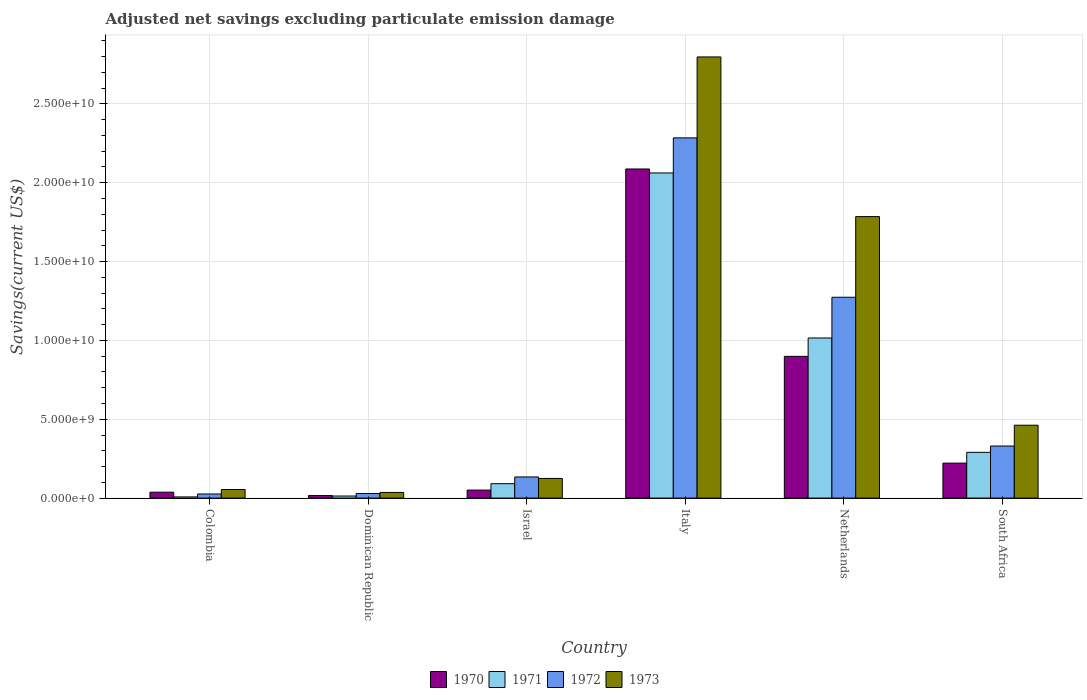How many bars are there on the 1st tick from the left?
Provide a succinct answer. 4. How many bars are there on the 3rd tick from the right?
Offer a very short reply. 4. What is the label of the 3rd group of bars from the left?
Make the answer very short. Israel. In how many cases, is the number of bars for a given country not equal to the number of legend labels?
Provide a succinct answer. 0. What is the adjusted net savings in 1972 in Netherlands?
Provide a succinct answer. 1.27e+1. Across all countries, what is the maximum adjusted net savings in 1972?
Make the answer very short. 2.28e+1. Across all countries, what is the minimum adjusted net savings in 1973?
Give a very brief answer. 3.58e+08. In which country was the adjusted net savings in 1972 minimum?
Your answer should be compact. Colombia. What is the total adjusted net savings in 1972 in the graph?
Your answer should be compact. 4.08e+1. What is the difference between the adjusted net savings in 1970 in Dominican Republic and that in South Africa?
Your answer should be compact. -2.06e+09. What is the difference between the adjusted net savings in 1972 in South Africa and the adjusted net savings in 1971 in Israel?
Your answer should be very brief. 2.39e+09. What is the average adjusted net savings in 1973 per country?
Give a very brief answer. 8.77e+09. What is the difference between the adjusted net savings of/in 1970 and adjusted net savings of/in 1972 in Italy?
Offer a terse response. -1.97e+09. What is the ratio of the adjusted net savings in 1972 in Italy to that in Netherlands?
Make the answer very short. 1.79. Is the difference between the adjusted net savings in 1970 in Colombia and Italy greater than the difference between the adjusted net savings in 1972 in Colombia and Italy?
Ensure brevity in your answer.  Yes. What is the difference between the highest and the second highest adjusted net savings in 1973?
Offer a terse response. -1.32e+1. What is the difference between the highest and the lowest adjusted net savings in 1973?
Your response must be concise. 2.76e+1. In how many countries, is the adjusted net savings in 1973 greater than the average adjusted net savings in 1973 taken over all countries?
Your response must be concise. 2. Is the sum of the adjusted net savings in 1972 in Israel and South Africa greater than the maximum adjusted net savings in 1971 across all countries?
Your answer should be compact. No. Are all the bars in the graph horizontal?
Keep it short and to the point. No. How many countries are there in the graph?
Give a very brief answer. 6. What is the difference between two consecutive major ticks on the Y-axis?
Your response must be concise. 5.00e+09. Where does the legend appear in the graph?
Offer a very short reply. Bottom center. What is the title of the graph?
Offer a terse response. Adjusted net savings excluding particulate emission damage. What is the label or title of the X-axis?
Give a very brief answer. Country. What is the label or title of the Y-axis?
Offer a terse response. Savings(current US$). What is the Savings(current US$) in 1970 in Colombia?
Your answer should be compact. 3.74e+08. What is the Savings(current US$) in 1971 in Colombia?
Offer a terse response. 7.46e+07. What is the Savings(current US$) in 1972 in Colombia?
Give a very brief answer. 2.60e+08. What is the Savings(current US$) of 1973 in Colombia?
Your answer should be very brief. 5.45e+08. What is the Savings(current US$) of 1970 in Dominican Republic?
Give a very brief answer. 1.61e+08. What is the Savings(current US$) in 1971 in Dominican Republic?
Keep it short and to the point. 1.32e+08. What is the Savings(current US$) of 1972 in Dominican Republic?
Give a very brief answer. 2.89e+08. What is the Savings(current US$) of 1973 in Dominican Republic?
Keep it short and to the point. 3.58e+08. What is the Savings(current US$) of 1970 in Israel?
Ensure brevity in your answer.  5.08e+08. What is the Savings(current US$) of 1971 in Israel?
Ensure brevity in your answer.  9.14e+08. What is the Savings(current US$) of 1972 in Israel?
Ensure brevity in your answer.  1.34e+09. What is the Savings(current US$) in 1973 in Israel?
Your response must be concise. 1.25e+09. What is the Savings(current US$) in 1970 in Italy?
Your answer should be compact. 2.09e+1. What is the Savings(current US$) of 1971 in Italy?
Make the answer very short. 2.06e+1. What is the Savings(current US$) in 1972 in Italy?
Keep it short and to the point. 2.28e+1. What is the Savings(current US$) in 1973 in Italy?
Give a very brief answer. 2.80e+1. What is the Savings(current US$) in 1970 in Netherlands?
Provide a short and direct response. 8.99e+09. What is the Savings(current US$) in 1971 in Netherlands?
Ensure brevity in your answer.  1.02e+1. What is the Savings(current US$) in 1972 in Netherlands?
Your answer should be very brief. 1.27e+1. What is the Savings(current US$) in 1973 in Netherlands?
Your response must be concise. 1.79e+1. What is the Savings(current US$) of 1970 in South Africa?
Keep it short and to the point. 2.22e+09. What is the Savings(current US$) in 1971 in South Africa?
Your response must be concise. 2.90e+09. What is the Savings(current US$) in 1972 in South Africa?
Your answer should be compact. 3.30e+09. What is the Savings(current US$) in 1973 in South Africa?
Your response must be concise. 4.62e+09. Across all countries, what is the maximum Savings(current US$) in 1970?
Offer a terse response. 2.09e+1. Across all countries, what is the maximum Savings(current US$) in 1971?
Your response must be concise. 2.06e+1. Across all countries, what is the maximum Savings(current US$) in 1972?
Ensure brevity in your answer.  2.28e+1. Across all countries, what is the maximum Savings(current US$) in 1973?
Provide a succinct answer. 2.80e+1. Across all countries, what is the minimum Savings(current US$) in 1970?
Offer a terse response. 1.61e+08. Across all countries, what is the minimum Savings(current US$) in 1971?
Provide a short and direct response. 7.46e+07. Across all countries, what is the minimum Savings(current US$) of 1972?
Your answer should be very brief. 2.60e+08. Across all countries, what is the minimum Savings(current US$) of 1973?
Offer a terse response. 3.58e+08. What is the total Savings(current US$) in 1970 in the graph?
Give a very brief answer. 3.31e+1. What is the total Savings(current US$) of 1971 in the graph?
Keep it short and to the point. 3.48e+1. What is the total Savings(current US$) of 1972 in the graph?
Offer a terse response. 4.08e+1. What is the total Savings(current US$) of 1973 in the graph?
Make the answer very short. 5.26e+1. What is the difference between the Savings(current US$) of 1970 in Colombia and that in Dominican Republic?
Your answer should be very brief. 2.13e+08. What is the difference between the Savings(current US$) in 1971 in Colombia and that in Dominican Republic?
Your response must be concise. -5.69e+07. What is the difference between the Savings(current US$) of 1972 in Colombia and that in Dominican Republic?
Offer a terse response. -2.84e+07. What is the difference between the Savings(current US$) of 1973 in Colombia and that in Dominican Republic?
Offer a very short reply. 1.87e+08. What is the difference between the Savings(current US$) of 1970 in Colombia and that in Israel?
Offer a terse response. -1.34e+08. What is the difference between the Savings(current US$) of 1971 in Colombia and that in Israel?
Your response must be concise. -8.40e+08. What is the difference between the Savings(current US$) in 1972 in Colombia and that in Israel?
Make the answer very short. -1.08e+09. What is the difference between the Savings(current US$) of 1973 in Colombia and that in Israel?
Make the answer very short. -7.02e+08. What is the difference between the Savings(current US$) in 1970 in Colombia and that in Italy?
Make the answer very short. -2.05e+1. What is the difference between the Savings(current US$) of 1971 in Colombia and that in Italy?
Make the answer very short. -2.05e+1. What is the difference between the Savings(current US$) of 1972 in Colombia and that in Italy?
Ensure brevity in your answer.  -2.26e+1. What is the difference between the Savings(current US$) in 1973 in Colombia and that in Italy?
Ensure brevity in your answer.  -2.74e+1. What is the difference between the Savings(current US$) in 1970 in Colombia and that in Netherlands?
Give a very brief answer. -8.61e+09. What is the difference between the Savings(current US$) of 1971 in Colombia and that in Netherlands?
Your answer should be compact. -1.01e+1. What is the difference between the Savings(current US$) in 1972 in Colombia and that in Netherlands?
Offer a very short reply. -1.25e+1. What is the difference between the Savings(current US$) in 1973 in Colombia and that in Netherlands?
Offer a very short reply. -1.73e+1. What is the difference between the Savings(current US$) of 1970 in Colombia and that in South Africa?
Offer a very short reply. -1.84e+09. What is the difference between the Savings(current US$) of 1971 in Colombia and that in South Africa?
Ensure brevity in your answer.  -2.83e+09. What is the difference between the Savings(current US$) of 1972 in Colombia and that in South Africa?
Give a very brief answer. -3.04e+09. What is the difference between the Savings(current US$) of 1973 in Colombia and that in South Africa?
Offer a terse response. -4.08e+09. What is the difference between the Savings(current US$) in 1970 in Dominican Republic and that in Israel?
Provide a short and direct response. -3.47e+08. What is the difference between the Savings(current US$) of 1971 in Dominican Republic and that in Israel?
Give a very brief answer. -7.83e+08. What is the difference between the Savings(current US$) of 1972 in Dominican Republic and that in Israel?
Make the answer very short. -1.05e+09. What is the difference between the Savings(current US$) of 1973 in Dominican Republic and that in Israel?
Keep it short and to the point. -8.89e+08. What is the difference between the Savings(current US$) in 1970 in Dominican Republic and that in Italy?
Your answer should be compact. -2.07e+1. What is the difference between the Savings(current US$) in 1971 in Dominican Republic and that in Italy?
Give a very brief answer. -2.05e+1. What is the difference between the Savings(current US$) in 1972 in Dominican Republic and that in Italy?
Your answer should be compact. -2.26e+1. What is the difference between the Savings(current US$) of 1973 in Dominican Republic and that in Italy?
Provide a succinct answer. -2.76e+1. What is the difference between the Savings(current US$) of 1970 in Dominican Republic and that in Netherlands?
Offer a very short reply. -8.83e+09. What is the difference between the Savings(current US$) in 1971 in Dominican Republic and that in Netherlands?
Offer a terse response. -1.00e+1. What is the difference between the Savings(current US$) in 1972 in Dominican Republic and that in Netherlands?
Ensure brevity in your answer.  -1.24e+1. What is the difference between the Savings(current US$) of 1973 in Dominican Republic and that in Netherlands?
Your answer should be very brief. -1.75e+1. What is the difference between the Savings(current US$) in 1970 in Dominican Republic and that in South Africa?
Keep it short and to the point. -2.06e+09. What is the difference between the Savings(current US$) of 1971 in Dominican Republic and that in South Africa?
Make the answer very short. -2.77e+09. What is the difference between the Savings(current US$) in 1972 in Dominican Republic and that in South Africa?
Give a very brief answer. -3.01e+09. What is the difference between the Savings(current US$) in 1973 in Dominican Republic and that in South Africa?
Offer a terse response. -4.26e+09. What is the difference between the Savings(current US$) in 1970 in Israel and that in Italy?
Your answer should be very brief. -2.04e+1. What is the difference between the Savings(current US$) in 1971 in Israel and that in Italy?
Provide a succinct answer. -1.97e+1. What is the difference between the Savings(current US$) of 1972 in Israel and that in Italy?
Your response must be concise. -2.15e+1. What is the difference between the Savings(current US$) in 1973 in Israel and that in Italy?
Offer a terse response. -2.67e+1. What is the difference between the Savings(current US$) of 1970 in Israel and that in Netherlands?
Offer a terse response. -8.48e+09. What is the difference between the Savings(current US$) of 1971 in Israel and that in Netherlands?
Ensure brevity in your answer.  -9.24e+09. What is the difference between the Savings(current US$) in 1972 in Israel and that in Netherlands?
Give a very brief answer. -1.14e+1. What is the difference between the Savings(current US$) in 1973 in Israel and that in Netherlands?
Provide a short and direct response. -1.66e+1. What is the difference between the Savings(current US$) in 1970 in Israel and that in South Africa?
Offer a terse response. -1.71e+09. What is the difference between the Savings(current US$) of 1971 in Israel and that in South Africa?
Ensure brevity in your answer.  -1.99e+09. What is the difference between the Savings(current US$) in 1972 in Israel and that in South Africa?
Provide a succinct answer. -1.96e+09. What is the difference between the Savings(current US$) of 1973 in Israel and that in South Africa?
Offer a very short reply. -3.38e+09. What is the difference between the Savings(current US$) of 1970 in Italy and that in Netherlands?
Provide a short and direct response. 1.19e+1. What is the difference between the Savings(current US$) of 1971 in Italy and that in Netherlands?
Keep it short and to the point. 1.05e+1. What is the difference between the Savings(current US$) of 1972 in Italy and that in Netherlands?
Your answer should be very brief. 1.01e+1. What is the difference between the Savings(current US$) of 1973 in Italy and that in Netherlands?
Your answer should be compact. 1.01e+1. What is the difference between the Savings(current US$) of 1970 in Italy and that in South Africa?
Your answer should be very brief. 1.87e+1. What is the difference between the Savings(current US$) in 1971 in Italy and that in South Africa?
Offer a very short reply. 1.77e+1. What is the difference between the Savings(current US$) in 1972 in Italy and that in South Africa?
Keep it short and to the point. 1.95e+1. What is the difference between the Savings(current US$) of 1973 in Italy and that in South Africa?
Keep it short and to the point. 2.34e+1. What is the difference between the Savings(current US$) of 1970 in Netherlands and that in South Africa?
Your answer should be compact. 6.77e+09. What is the difference between the Savings(current US$) of 1971 in Netherlands and that in South Africa?
Your response must be concise. 7.25e+09. What is the difference between the Savings(current US$) in 1972 in Netherlands and that in South Africa?
Make the answer very short. 9.43e+09. What is the difference between the Savings(current US$) in 1973 in Netherlands and that in South Africa?
Provide a succinct answer. 1.32e+1. What is the difference between the Savings(current US$) in 1970 in Colombia and the Savings(current US$) in 1971 in Dominican Republic?
Ensure brevity in your answer.  2.42e+08. What is the difference between the Savings(current US$) of 1970 in Colombia and the Savings(current US$) of 1972 in Dominican Republic?
Your answer should be very brief. 8.52e+07. What is the difference between the Savings(current US$) in 1970 in Colombia and the Savings(current US$) in 1973 in Dominican Republic?
Make the answer very short. 1.57e+07. What is the difference between the Savings(current US$) in 1971 in Colombia and the Savings(current US$) in 1972 in Dominican Republic?
Your answer should be very brief. -2.14e+08. What is the difference between the Savings(current US$) of 1971 in Colombia and the Savings(current US$) of 1973 in Dominican Republic?
Your answer should be very brief. -2.84e+08. What is the difference between the Savings(current US$) of 1972 in Colombia and the Savings(current US$) of 1973 in Dominican Republic?
Your answer should be very brief. -9.79e+07. What is the difference between the Savings(current US$) in 1970 in Colombia and the Savings(current US$) in 1971 in Israel?
Provide a short and direct response. -5.40e+08. What is the difference between the Savings(current US$) in 1970 in Colombia and the Savings(current US$) in 1972 in Israel?
Your answer should be compact. -9.67e+08. What is the difference between the Savings(current US$) of 1970 in Colombia and the Savings(current US$) of 1973 in Israel?
Your answer should be compact. -8.73e+08. What is the difference between the Savings(current US$) of 1971 in Colombia and the Savings(current US$) of 1972 in Israel?
Offer a terse response. -1.27e+09. What is the difference between the Savings(current US$) of 1971 in Colombia and the Savings(current US$) of 1973 in Israel?
Offer a terse response. -1.17e+09. What is the difference between the Savings(current US$) of 1972 in Colombia and the Savings(current US$) of 1973 in Israel?
Keep it short and to the point. -9.87e+08. What is the difference between the Savings(current US$) of 1970 in Colombia and the Savings(current US$) of 1971 in Italy?
Your answer should be very brief. -2.02e+1. What is the difference between the Savings(current US$) in 1970 in Colombia and the Savings(current US$) in 1972 in Italy?
Give a very brief answer. -2.25e+1. What is the difference between the Savings(current US$) of 1970 in Colombia and the Savings(current US$) of 1973 in Italy?
Make the answer very short. -2.76e+1. What is the difference between the Savings(current US$) of 1971 in Colombia and the Savings(current US$) of 1972 in Italy?
Ensure brevity in your answer.  -2.28e+1. What is the difference between the Savings(current US$) in 1971 in Colombia and the Savings(current US$) in 1973 in Italy?
Your answer should be compact. -2.79e+1. What is the difference between the Savings(current US$) of 1972 in Colombia and the Savings(current US$) of 1973 in Italy?
Your response must be concise. -2.77e+1. What is the difference between the Savings(current US$) of 1970 in Colombia and the Savings(current US$) of 1971 in Netherlands?
Provide a succinct answer. -9.78e+09. What is the difference between the Savings(current US$) of 1970 in Colombia and the Savings(current US$) of 1972 in Netherlands?
Offer a terse response. -1.24e+1. What is the difference between the Savings(current US$) of 1970 in Colombia and the Savings(current US$) of 1973 in Netherlands?
Offer a very short reply. -1.75e+1. What is the difference between the Savings(current US$) of 1971 in Colombia and the Savings(current US$) of 1972 in Netherlands?
Your answer should be very brief. -1.27e+1. What is the difference between the Savings(current US$) of 1971 in Colombia and the Savings(current US$) of 1973 in Netherlands?
Offer a very short reply. -1.78e+1. What is the difference between the Savings(current US$) in 1972 in Colombia and the Savings(current US$) in 1973 in Netherlands?
Your response must be concise. -1.76e+1. What is the difference between the Savings(current US$) of 1970 in Colombia and the Savings(current US$) of 1971 in South Africa?
Ensure brevity in your answer.  -2.53e+09. What is the difference between the Savings(current US$) of 1970 in Colombia and the Savings(current US$) of 1972 in South Africa?
Offer a very short reply. -2.93e+09. What is the difference between the Savings(current US$) in 1970 in Colombia and the Savings(current US$) in 1973 in South Africa?
Provide a succinct answer. -4.25e+09. What is the difference between the Savings(current US$) in 1971 in Colombia and the Savings(current US$) in 1972 in South Africa?
Your answer should be very brief. -3.23e+09. What is the difference between the Savings(current US$) in 1971 in Colombia and the Savings(current US$) in 1973 in South Africa?
Keep it short and to the point. -4.55e+09. What is the difference between the Savings(current US$) in 1972 in Colombia and the Savings(current US$) in 1973 in South Africa?
Offer a terse response. -4.36e+09. What is the difference between the Savings(current US$) of 1970 in Dominican Republic and the Savings(current US$) of 1971 in Israel?
Ensure brevity in your answer.  -7.53e+08. What is the difference between the Savings(current US$) in 1970 in Dominican Republic and the Savings(current US$) in 1972 in Israel?
Give a very brief answer. -1.18e+09. What is the difference between the Savings(current US$) in 1970 in Dominican Republic and the Savings(current US$) in 1973 in Israel?
Provide a succinct answer. -1.09e+09. What is the difference between the Savings(current US$) in 1971 in Dominican Republic and the Savings(current US$) in 1972 in Israel?
Your answer should be very brief. -1.21e+09. What is the difference between the Savings(current US$) in 1971 in Dominican Republic and the Savings(current US$) in 1973 in Israel?
Offer a very short reply. -1.12e+09. What is the difference between the Savings(current US$) in 1972 in Dominican Republic and the Savings(current US$) in 1973 in Israel?
Your response must be concise. -9.58e+08. What is the difference between the Savings(current US$) in 1970 in Dominican Republic and the Savings(current US$) in 1971 in Italy?
Ensure brevity in your answer.  -2.05e+1. What is the difference between the Savings(current US$) of 1970 in Dominican Republic and the Savings(current US$) of 1972 in Italy?
Give a very brief answer. -2.27e+1. What is the difference between the Savings(current US$) of 1970 in Dominican Republic and the Savings(current US$) of 1973 in Italy?
Make the answer very short. -2.78e+1. What is the difference between the Savings(current US$) in 1971 in Dominican Republic and the Savings(current US$) in 1972 in Italy?
Provide a short and direct response. -2.27e+1. What is the difference between the Savings(current US$) in 1971 in Dominican Republic and the Savings(current US$) in 1973 in Italy?
Make the answer very short. -2.78e+1. What is the difference between the Savings(current US$) of 1972 in Dominican Republic and the Savings(current US$) of 1973 in Italy?
Your answer should be very brief. -2.77e+1. What is the difference between the Savings(current US$) in 1970 in Dominican Republic and the Savings(current US$) in 1971 in Netherlands?
Your response must be concise. -9.99e+09. What is the difference between the Savings(current US$) in 1970 in Dominican Republic and the Savings(current US$) in 1972 in Netherlands?
Provide a succinct answer. -1.26e+1. What is the difference between the Savings(current US$) of 1970 in Dominican Republic and the Savings(current US$) of 1973 in Netherlands?
Provide a succinct answer. -1.77e+1. What is the difference between the Savings(current US$) of 1971 in Dominican Republic and the Savings(current US$) of 1972 in Netherlands?
Make the answer very short. -1.26e+1. What is the difference between the Savings(current US$) in 1971 in Dominican Republic and the Savings(current US$) in 1973 in Netherlands?
Make the answer very short. -1.77e+1. What is the difference between the Savings(current US$) of 1972 in Dominican Republic and the Savings(current US$) of 1973 in Netherlands?
Provide a succinct answer. -1.76e+1. What is the difference between the Savings(current US$) of 1970 in Dominican Republic and the Savings(current US$) of 1971 in South Africa?
Provide a short and direct response. -2.74e+09. What is the difference between the Savings(current US$) in 1970 in Dominican Republic and the Savings(current US$) in 1972 in South Africa?
Provide a short and direct response. -3.14e+09. What is the difference between the Savings(current US$) of 1970 in Dominican Republic and the Savings(current US$) of 1973 in South Africa?
Provide a short and direct response. -4.46e+09. What is the difference between the Savings(current US$) of 1971 in Dominican Republic and the Savings(current US$) of 1972 in South Africa?
Your answer should be compact. -3.17e+09. What is the difference between the Savings(current US$) in 1971 in Dominican Republic and the Savings(current US$) in 1973 in South Africa?
Provide a succinct answer. -4.49e+09. What is the difference between the Savings(current US$) of 1972 in Dominican Republic and the Savings(current US$) of 1973 in South Africa?
Make the answer very short. -4.33e+09. What is the difference between the Savings(current US$) in 1970 in Israel and the Savings(current US$) in 1971 in Italy?
Your response must be concise. -2.01e+1. What is the difference between the Savings(current US$) in 1970 in Israel and the Savings(current US$) in 1972 in Italy?
Offer a very short reply. -2.23e+1. What is the difference between the Savings(current US$) in 1970 in Israel and the Savings(current US$) in 1973 in Italy?
Offer a very short reply. -2.75e+1. What is the difference between the Savings(current US$) of 1971 in Israel and the Savings(current US$) of 1972 in Italy?
Offer a very short reply. -2.19e+1. What is the difference between the Savings(current US$) in 1971 in Israel and the Savings(current US$) in 1973 in Italy?
Make the answer very short. -2.71e+1. What is the difference between the Savings(current US$) in 1972 in Israel and the Savings(current US$) in 1973 in Italy?
Provide a short and direct response. -2.66e+1. What is the difference between the Savings(current US$) in 1970 in Israel and the Savings(current US$) in 1971 in Netherlands?
Your response must be concise. -9.65e+09. What is the difference between the Savings(current US$) in 1970 in Israel and the Savings(current US$) in 1972 in Netherlands?
Keep it short and to the point. -1.22e+1. What is the difference between the Savings(current US$) in 1970 in Israel and the Savings(current US$) in 1973 in Netherlands?
Offer a terse response. -1.73e+1. What is the difference between the Savings(current US$) of 1971 in Israel and the Savings(current US$) of 1972 in Netherlands?
Offer a terse response. -1.18e+1. What is the difference between the Savings(current US$) in 1971 in Israel and the Savings(current US$) in 1973 in Netherlands?
Ensure brevity in your answer.  -1.69e+1. What is the difference between the Savings(current US$) of 1972 in Israel and the Savings(current US$) of 1973 in Netherlands?
Keep it short and to the point. -1.65e+1. What is the difference between the Savings(current US$) of 1970 in Israel and the Savings(current US$) of 1971 in South Africa?
Your answer should be compact. -2.39e+09. What is the difference between the Savings(current US$) in 1970 in Israel and the Savings(current US$) in 1972 in South Africa?
Give a very brief answer. -2.79e+09. What is the difference between the Savings(current US$) in 1970 in Israel and the Savings(current US$) in 1973 in South Africa?
Your answer should be compact. -4.11e+09. What is the difference between the Savings(current US$) in 1971 in Israel and the Savings(current US$) in 1972 in South Africa?
Ensure brevity in your answer.  -2.39e+09. What is the difference between the Savings(current US$) of 1971 in Israel and the Savings(current US$) of 1973 in South Africa?
Your response must be concise. -3.71e+09. What is the difference between the Savings(current US$) in 1972 in Israel and the Savings(current US$) in 1973 in South Africa?
Provide a short and direct response. -3.28e+09. What is the difference between the Savings(current US$) of 1970 in Italy and the Savings(current US$) of 1971 in Netherlands?
Offer a very short reply. 1.07e+1. What is the difference between the Savings(current US$) of 1970 in Italy and the Savings(current US$) of 1972 in Netherlands?
Make the answer very short. 8.14e+09. What is the difference between the Savings(current US$) in 1970 in Italy and the Savings(current US$) in 1973 in Netherlands?
Offer a terse response. 3.02e+09. What is the difference between the Savings(current US$) of 1971 in Italy and the Savings(current US$) of 1972 in Netherlands?
Provide a short and direct response. 7.88e+09. What is the difference between the Savings(current US$) of 1971 in Italy and the Savings(current US$) of 1973 in Netherlands?
Offer a terse response. 2.77e+09. What is the difference between the Savings(current US$) of 1972 in Italy and the Savings(current US$) of 1973 in Netherlands?
Your answer should be very brief. 4.99e+09. What is the difference between the Savings(current US$) in 1970 in Italy and the Savings(current US$) in 1971 in South Africa?
Your answer should be very brief. 1.80e+1. What is the difference between the Savings(current US$) in 1970 in Italy and the Savings(current US$) in 1972 in South Africa?
Provide a short and direct response. 1.76e+1. What is the difference between the Savings(current US$) in 1970 in Italy and the Savings(current US$) in 1973 in South Africa?
Your answer should be very brief. 1.62e+1. What is the difference between the Savings(current US$) in 1971 in Italy and the Savings(current US$) in 1972 in South Africa?
Your response must be concise. 1.73e+1. What is the difference between the Savings(current US$) of 1971 in Italy and the Savings(current US$) of 1973 in South Africa?
Offer a terse response. 1.60e+1. What is the difference between the Savings(current US$) in 1972 in Italy and the Savings(current US$) in 1973 in South Africa?
Your answer should be very brief. 1.82e+1. What is the difference between the Savings(current US$) of 1970 in Netherlands and the Savings(current US$) of 1971 in South Africa?
Your response must be concise. 6.09e+09. What is the difference between the Savings(current US$) in 1970 in Netherlands and the Savings(current US$) in 1972 in South Africa?
Make the answer very short. 5.69e+09. What is the difference between the Savings(current US$) of 1970 in Netherlands and the Savings(current US$) of 1973 in South Africa?
Your response must be concise. 4.37e+09. What is the difference between the Savings(current US$) in 1971 in Netherlands and the Savings(current US$) in 1972 in South Africa?
Provide a short and direct response. 6.85e+09. What is the difference between the Savings(current US$) of 1971 in Netherlands and the Savings(current US$) of 1973 in South Africa?
Your answer should be very brief. 5.53e+09. What is the difference between the Savings(current US$) in 1972 in Netherlands and the Savings(current US$) in 1973 in South Africa?
Ensure brevity in your answer.  8.11e+09. What is the average Savings(current US$) of 1970 per country?
Ensure brevity in your answer.  5.52e+09. What is the average Savings(current US$) of 1971 per country?
Keep it short and to the point. 5.80e+09. What is the average Savings(current US$) of 1972 per country?
Offer a terse response. 6.80e+09. What is the average Savings(current US$) of 1973 per country?
Provide a short and direct response. 8.77e+09. What is the difference between the Savings(current US$) of 1970 and Savings(current US$) of 1971 in Colombia?
Your answer should be compact. 2.99e+08. What is the difference between the Savings(current US$) of 1970 and Savings(current US$) of 1972 in Colombia?
Provide a succinct answer. 1.14e+08. What is the difference between the Savings(current US$) of 1970 and Savings(current US$) of 1973 in Colombia?
Your answer should be very brief. -1.71e+08. What is the difference between the Savings(current US$) in 1971 and Savings(current US$) in 1972 in Colombia?
Your response must be concise. -1.86e+08. What is the difference between the Savings(current US$) of 1971 and Savings(current US$) of 1973 in Colombia?
Your answer should be very brief. -4.70e+08. What is the difference between the Savings(current US$) of 1972 and Savings(current US$) of 1973 in Colombia?
Offer a terse response. -2.85e+08. What is the difference between the Savings(current US$) of 1970 and Savings(current US$) of 1971 in Dominican Republic?
Your answer should be compact. 2.96e+07. What is the difference between the Savings(current US$) in 1970 and Savings(current US$) in 1972 in Dominican Republic?
Provide a short and direct response. -1.28e+08. What is the difference between the Savings(current US$) of 1970 and Savings(current US$) of 1973 in Dominican Republic?
Keep it short and to the point. -1.97e+08. What is the difference between the Savings(current US$) of 1971 and Savings(current US$) of 1972 in Dominican Republic?
Make the answer very short. -1.57e+08. What is the difference between the Savings(current US$) in 1971 and Savings(current US$) in 1973 in Dominican Republic?
Your answer should be very brief. -2.27e+08. What is the difference between the Savings(current US$) of 1972 and Savings(current US$) of 1973 in Dominican Republic?
Your answer should be compact. -6.95e+07. What is the difference between the Savings(current US$) in 1970 and Savings(current US$) in 1971 in Israel?
Provide a succinct answer. -4.06e+08. What is the difference between the Savings(current US$) in 1970 and Savings(current US$) in 1972 in Israel?
Your response must be concise. -8.33e+08. What is the difference between the Savings(current US$) of 1970 and Savings(current US$) of 1973 in Israel?
Your response must be concise. -7.39e+08. What is the difference between the Savings(current US$) in 1971 and Savings(current US$) in 1972 in Israel?
Make the answer very short. -4.27e+08. What is the difference between the Savings(current US$) of 1971 and Savings(current US$) of 1973 in Israel?
Provide a succinct answer. -3.33e+08. What is the difference between the Savings(current US$) in 1972 and Savings(current US$) in 1973 in Israel?
Give a very brief answer. 9.40e+07. What is the difference between the Savings(current US$) of 1970 and Savings(current US$) of 1971 in Italy?
Make the answer very short. 2.53e+08. What is the difference between the Savings(current US$) of 1970 and Savings(current US$) of 1972 in Italy?
Keep it short and to the point. -1.97e+09. What is the difference between the Savings(current US$) of 1970 and Savings(current US$) of 1973 in Italy?
Your answer should be compact. -7.11e+09. What is the difference between the Savings(current US$) of 1971 and Savings(current US$) of 1972 in Italy?
Give a very brief answer. -2.23e+09. What is the difference between the Savings(current US$) in 1971 and Savings(current US$) in 1973 in Italy?
Your response must be concise. -7.36e+09. What is the difference between the Savings(current US$) of 1972 and Savings(current US$) of 1973 in Italy?
Give a very brief answer. -5.13e+09. What is the difference between the Savings(current US$) in 1970 and Savings(current US$) in 1971 in Netherlands?
Make the answer very short. -1.17e+09. What is the difference between the Savings(current US$) in 1970 and Savings(current US$) in 1972 in Netherlands?
Keep it short and to the point. -3.75e+09. What is the difference between the Savings(current US$) in 1970 and Savings(current US$) in 1973 in Netherlands?
Offer a terse response. -8.86e+09. What is the difference between the Savings(current US$) of 1971 and Savings(current US$) of 1972 in Netherlands?
Offer a terse response. -2.58e+09. What is the difference between the Savings(current US$) of 1971 and Savings(current US$) of 1973 in Netherlands?
Your answer should be compact. -7.70e+09. What is the difference between the Savings(current US$) in 1972 and Savings(current US$) in 1973 in Netherlands?
Give a very brief answer. -5.11e+09. What is the difference between the Savings(current US$) of 1970 and Savings(current US$) of 1971 in South Africa?
Provide a succinct answer. -6.85e+08. What is the difference between the Savings(current US$) of 1970 and Savings(current US$) of 1972 in South Africa?
Offer a terse response. -1.08e+09. What is the difference between the Savings(current US$) of 1970 and Savings(current US$) of 1973 in South Africa?
Provide a succinct answer. -2.40e+09. What is the difference between the Savings(current US$) of 1971 and Savings(current US$) of 1972 in South Africa?
Offer a very short reply. -4.00e+08. What is the difference between the Savings(current US$) of 1971 and Savings(current US$) of 1973 in South Africa?
Offer a very short reply. -1.72e+09. What is the difference between the Savings(current US$) of 1972 and Savings(current US$) of 1973 in South Africa?
Ensure brevity in your answer.  -1.32e+09. What is the ratio of the Savings(current US$) of 1970 in Colombia to that in Dominican Republic?
Provide a succinct answer. 2.32. What is the ratio of the Savings(current US$) in 1971 in Colombia to that in Dominican Republic?
Offer a terse response. 0.57. What is the ratio of the Savings(current US$) of 1972 in Colombia to that in Dominican Republic?
Keep it short and to the point. 0.9. What is the ratio of the Savings(current US$) of 1973 in Colombia to that in Dominican Republic?
Make the answer very short. 1.52. What is the ratio of the Savings(current US$) of 1970 in Colombia to that in Israel?
Ensure brevity in your answer.  0.74. What is the ratio of the Savings(current US$) in 1971 in Colombia to that in Israel?
Ensure brevity in your answer.  0.08. What is the ratio of the Savings(current US$) of 1972 in Colombia to that in Israel?
Offer a very short reply. 0.19. What is the ratio of the Savings(current US$) in 1973 in Colombia to that in Israel?
Your answer should be very brief. 0.44. What is the ratio of the Savings(current US$) of 1970 in Colombia to that in Italy?
Give a very brief answer. 0.02. What is the ratio of the Savings(current US$) in 1971 in Colombia to that in Italy?
Keep it short and to the point. 0. What is the ratio of the Savings(current US$) of 1972 in Colombia to that in Italy?
Ensure brevity in your answer.  0.01. What is the ratio of the Savings(current US$) in 1973 in Colombia to that in Italy?
Make the answer very short. 0.02. What is the ratio of the Savings(current US$) of 1970 in Colombia to that in Netherlands?
Provide a succinct answer. 0.04. What is the ratio of the Savings(current US$) of 1971 in Colombia to that in Netherlands?
Offer a terse response. 0.01. What is the ratio of the Savings(current US$) in 1972 in Colombia to that in Netherlands?
Offer a very short reply. 0.02. What is the ratio of the Savings(current US$) in 1973 in Colombia to that in Netherlands?
Ensure brevity in your answer.  0.03. What is the ratio of the Savings(current US$) of 1970 in Colombia to that in South Africa?
Your response must be concise. 0.17. What is the ratio of the Savings(current US$) in 1971 in Colombia to that in South Africa?
Give a very brief answer. 0.03. What is the ratio of the Savings(current US$) in 1972 in Colombia to that in South Africa?
Your answer should be very brief. 0.08. What is the ratio of the Savings(current US$) of 1973 in Colombia to that in South Africa?
Provide a short and direct response. 0.12. What is the ratio of the Savings(current US$) in 1970 in Dominican Republic to that in Israel?
Offer a terse response. 0.32. What is the ratio of the Savings(current US$) of 1971 in Dominican Republic to that in Israel?
Your response must be concise. 0.14. What is the ratio of the Savings(current US$) in 1972 in Dominican Republic to that in Israel?
Provide a succinct answer. 0.22. What is the ratio of the Savings(current US$) of 1973 in Dominican Republic to that in Israel?
Make the answer very short. 0.29. What is the ratio of the Savings(current US$) in 1970 in Dominican Republic to that in Italy?
Provide a short and direct response. 0.01. What is the ratio of the Savings(current US$) of 1971 in Dominican Republic to that in Italy?
Make the answer very short. 0.01. What is the ratio of the Savings(current US$) in 1972 in Dominican Republic to that in Italy?
Your answer should be compact. 0.01. What is the ratio of the Savings(current US$) of 1973 in Dominican Republic to that in Italy?
Offer a terse response. 0.01. What is the ratio of the Savings(current US$) in 1970 in Dominican Republic to that in Netherlands?
Your response must be concise. 0.02. What is the ratio of the Savings(current US$) in 1971 in Dominican Republic to that in Netherlands?
Your answer should be very brief. 0.01. What is the ratio of the Savings(current US$) of 1972 in Dominican Republic to that in Netherlands?
Your answer should be compact. 0.02. What is the ratio of the Savings(current US$) of 1973 in Dominican Republic to that in Netherlands?
Your response must be concise. 0.02. What is the ratio of the Savings(current US$) in 1970 in Dominican Republic to that in South Africa?
Make the answer very short. 0.07. What is the ratio of the Savings(current US$) in 1971 in Dominican Republic to that in South Africa?
Offer a very short reply. 0.05. What is the ratio of the Savings(current US$) in 1972 in Dominican Republic to that in South Africa?
Your answer should be very brief. 0.09. What is the ratio of the Savings(current US$) in 1973 in Dominican Republic to that in South Africa?
Ensure brevity in your answer.  0.08. What is the ratio of the Savings(current US$) of 1970 in Israel to that in Italy?
Your response must be concise. 0.02. What is the ratio of the Savings(current US$) in 1971 in Israel to that in Italy?
Provide a succinct answer. 0.04. What is the ratio of the Savings(current US$) in 1972 in Israel to that in Italy?
Offer a terse response. 0.06. What is the ratio of the Savings(current US$) of 1973 in Israel to that in Italy?
Your response must be concise. 0.04. What is the ratio of the Savings(current US$) in 1970 in Israel to that in Netherlands?
Offer a terse response. 0.06. What is the ratio of the Savings(current US$) in 1971 in Israel to that in Netherlands?
Offer a very short reply. 0.09. What is the ratio of the Savings(current US$) of 1972 in Israel to that in Netherlands?
Make the answer very short. 0.11. What is the ratio of the Savings(current US$) of 1973 in Israel to that in Netherlands?
Your answer should be very brief. 0.07. What is the ratio of the Savings(current US$) of 1970 in Israel to that in South Africa?
Your answer should be compact. 0.23. What is the ratio of the Savings(current US$) in 1971 in Israel to that in South Africa?
Make the answer very short. 0.32. What is the ratio of the Savings(current US$) in 1972 in Israel to that in South Africa?
Your answer should be very brief. 0.41. What is the ratio of the Savings(current US$) in 1973 in Israel to that in South Africa?
Your response must be concise. 0.27. What is the ratio of the Savings(current US$) in 1970 in Italy to that in Netherlands?
Make the answer very short. 2.32. What is the ratio of the Savings(current US$) of 1971 in Italy to that in Netherlands?
Give a very brief answer. 2.03. What is the ratio of the Savings(current US$) of 1972 in Italy to that in Netherlands?
Your response must be concise. 1.79. What is the ratio of the Savings(current US$) of 1973 in Italy to that in Netherlands?
Keep it short and to the point. 1.57. What is the ratio of the Savings(current US$) of 1970 in Italy to that in South Africa?
Keep it short and to the point. 9.41. What is the ratio of the Savings(current US$) in 1971 in Italy to that in South Africa?
Your response must be concise. 7.1. What is the ratio of the Savings(current US$) of 1972 in Italy to that in South Africa?
Your answer should be compact. 6.92. What is the ratio of the Savings(current US$) in 1973 in Italy to that in South Africa?
Ensure brevity in your answer.  6.05. What is the ratio of the Savings(current US$) of 1970 in Netherlands to that in South Africa?
Offer a very short reply. 4.05. What is the ratio of the Savings(current US$) of 1971 in Netherlands to that in South Africa?
Keep it short and to the point. 3.5. What is the ratio of the Savings(current US$) in 1972 in Netherlands to that in South Africa?
Make the answer very short. 3.86. What is the ratio of the Savings(current US$) in 1973 in Netherlands to that in South Africa?
Make the answer very short. 3.86. What is the difference between the highest and the second highest Savings(current US$) in 1970?
Your answer should be very brief. 1.19e+1. What is the difference between the highest and the second highest Savings(current US$) in 1971?
Your answer should be compact. 1.05e+1. What is the difference between the highest and the second highest Savings(current US$) of 1972?
Your answer should be compact. 1.01e+1. What is the difference between the highest and the second highest Savings(current US$) in 1973?
Make the answer very short. 1.01e+1. What is the difference between the highest and the lowest Savings(current US$) in 1970?
Offer a very short reply. 2.07e+1. What is the difference between the highest and the lowest Savings(current US$) in 1971?
Your response must be concise. 2.05e+1. What is the difference between the highest and the lowest Savings(current US$) in 1972?
Ensure brevity in your answer.  2.26e+1. What is the difference between the highest and the lowest Savings(current US$) in 1973?
Provide a succinct answer. 2.76e+1. 